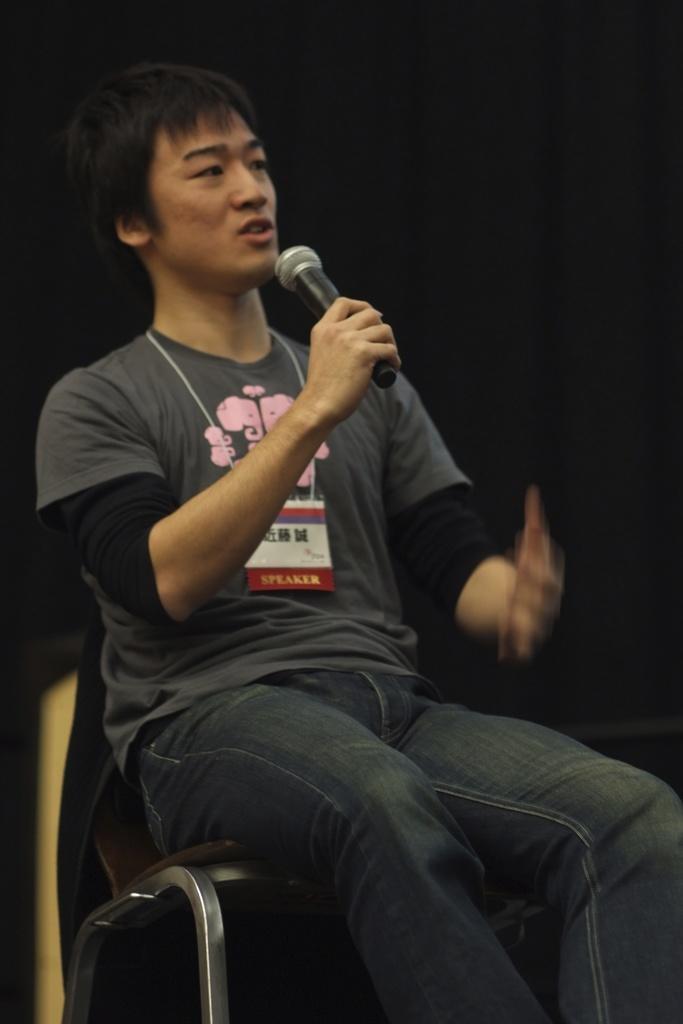Describe this image in one or two sentences. There is man sitting on a chair, holding a microphone in his right hand and he is speaking 